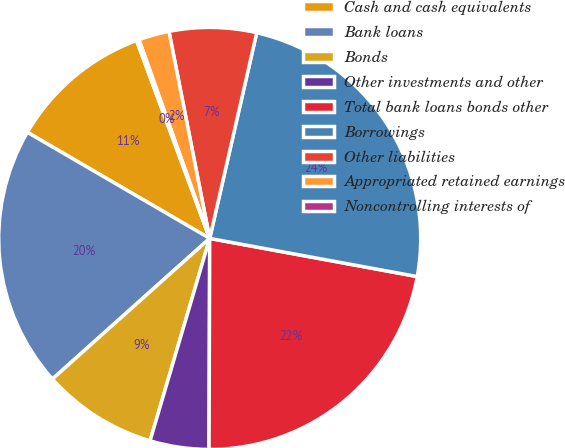<chart> <loc_0><loc_0><loc_500><loc_500><pie_chart><fcel>Cash and cash equivalents<fcel>Bank loans<fcel>Bonds<fcel>Other investments and other<fcel>Total bank loans bonds other<fcel>Borrowings<fcel>Other liabilities<fcel>Appropriated retained earnings<fcel>Noncontrolling interests of<nl><fcel>10.98%<fcel>20.0%<fcel>8.83%<fcel>4.51%<fcel>22.16%<fcel>24.32%<fcel>6.67%<fcel>2.35%<fcel>0.19%<nl></chart> 